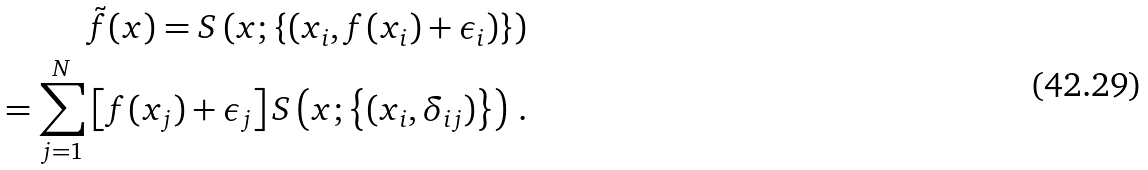Convert formula to latex. <formula><loc_0><loc_0><loc_500><loc_500>\tilde { f } ( x ) = S \left ( x ; \left \{ ( x _ { i } , f ( x _ { i } ) + \epsilon _ { i } ) \right \} \right ) \\ = \sum _ { j = 1 } ^ { N } \left [ f ( x _ { j } ) + \epsilon _ { j } \right ] S \left ( x ; \left \{ ( x _ { i } , \delta _ { i j } ) \right \} \right ) \, .</formula> 